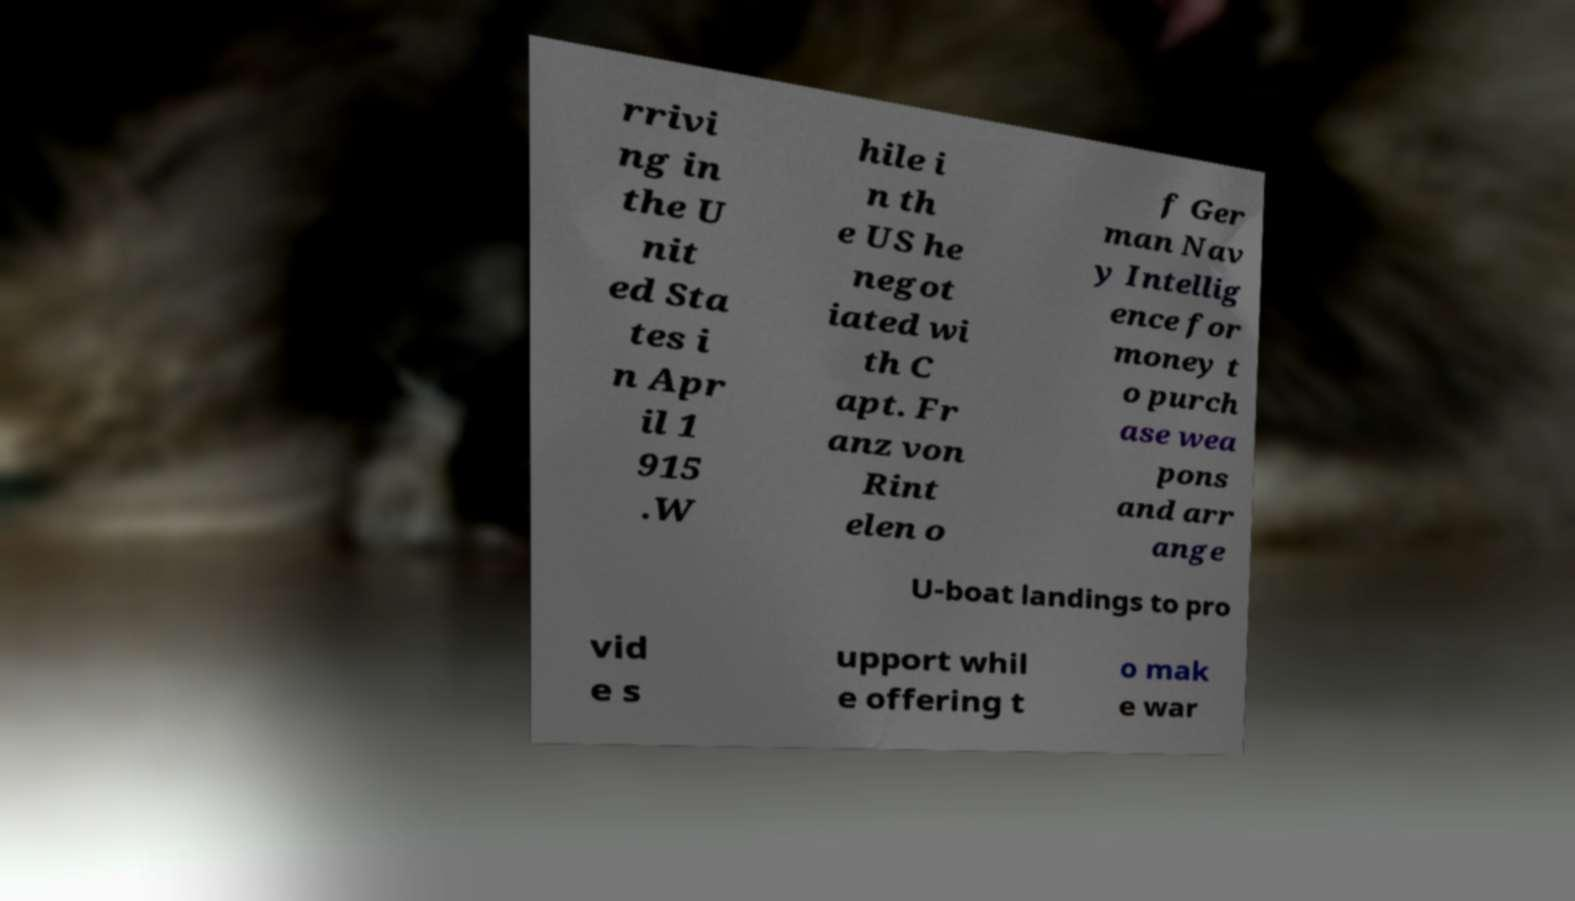There's text embedded in this image that I need extracted. Can you transcribe it verbatim? rrivi ng in the U nit ed Sta tes i n Apr il 1 915 .W hile i n th e US he negot iated wi th C apt. Fr anz von Rint elen o f Ger man Nav y Intellig ence for money t o purch ase wea pons and arr ange U-boat landings to pro vid e s upport whil e offering t o mak e war 